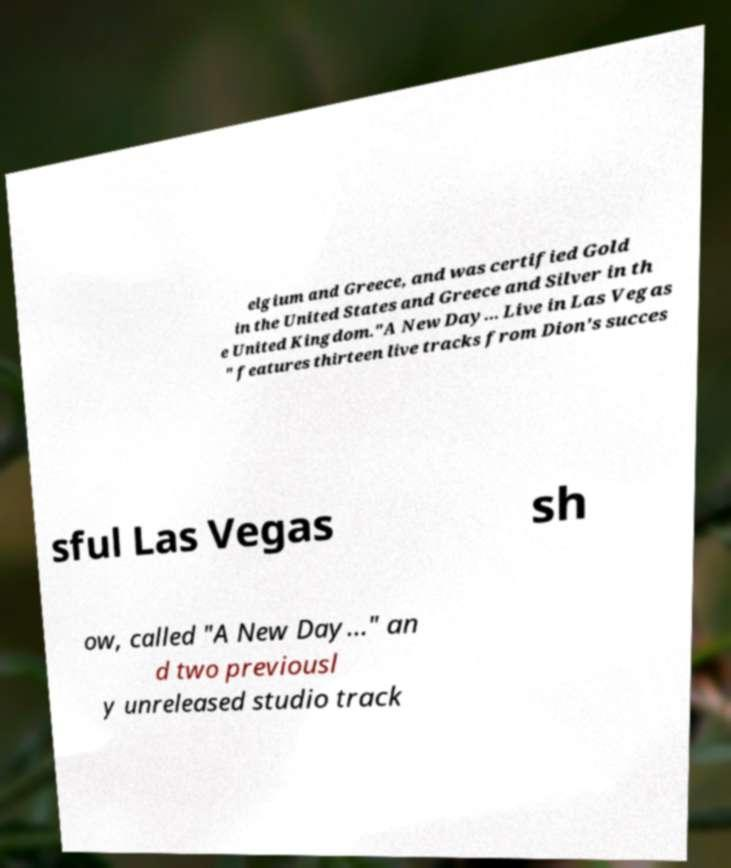Can you accurately transcribe the text from the provided image for me? elgium and Greece, and was certified Gold in the United States and Greece and Silver in th e United Kingdom."A New Day... Live in Las Vegas " features thirteen live tracks from Dion's succes sful Las Vegas sh ow, called "A New Day..." an d two previousl y unreleased studio track 